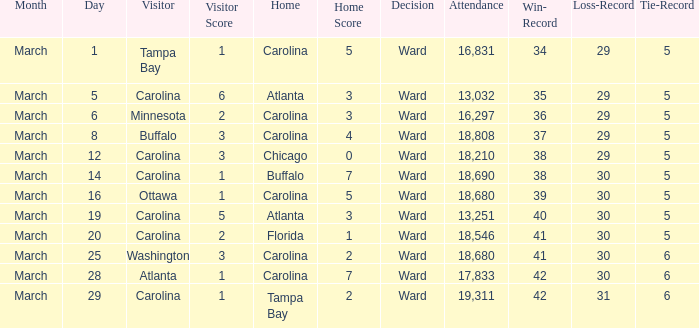What is the Record when Buffalo is at Home? 38–30–5. 